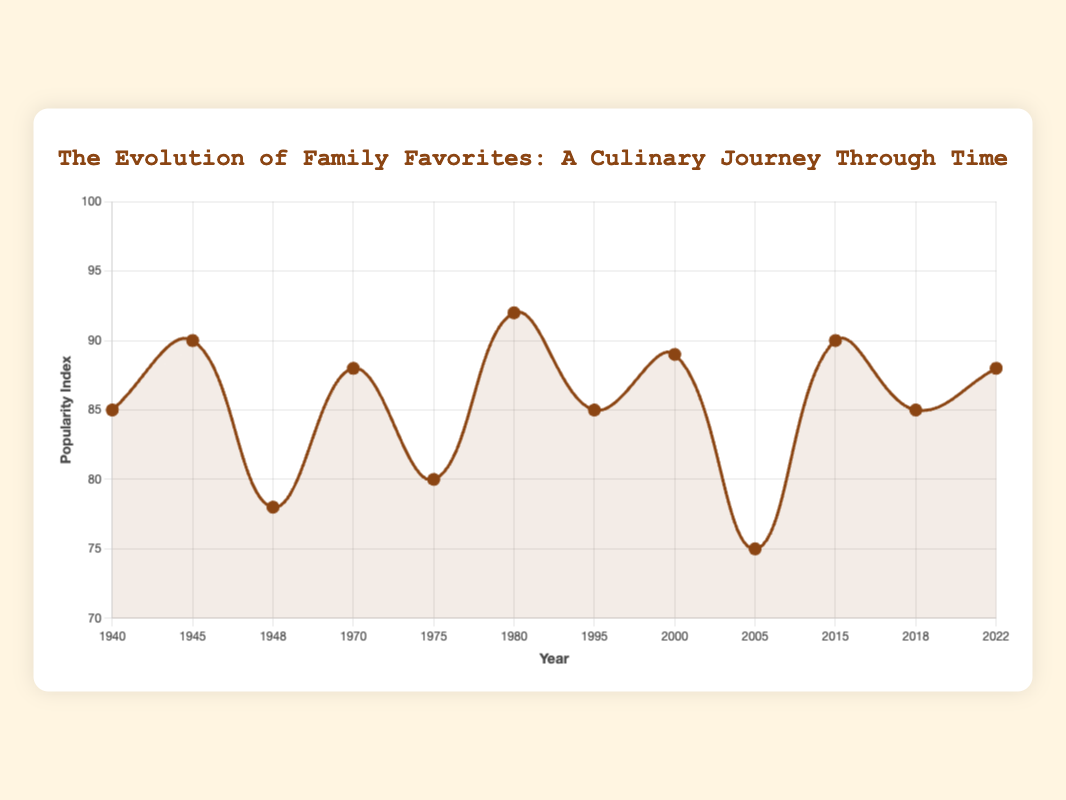What's the average popularity index for the recipes from the Great-Grandparents' generation? To find the average, sum the popularity indices of the recipes from the Great-Grandparents' generation (85 + 90 + 78 = 253) and then divide by the number of recipes (3). So, 253 / 3 ≈ 84.33
Answer: 84.33 Which generation has the highest peak in recipe popularity index, and what is this value? The peak of the popularity index can be identified as the highest point on the curve. The highest value is 92, which belongs to the Grandparents' generation (Chocolate Cake, 1980).
Answer: Grandparents, 92 How many recipes have a popularity index greater than 85? Identify the recipes with a popularity index greater than 85. They are Beef Stew (90), Spaghetti Bolognese (88), Chocolate Cake (92), Lasagna (89), Avocado Toast (90), Vegan Burgers (88). Count the recipes: 6.
Answer: 6 Visualize the data and identify the recipe with the lowest popularity index. What is it and from which year? Identify the lowest point on the curve to find the recipe with the lowest popularity index. This is the Cheeseburger with a popularity index of 75 from the year 2005.
Answer: Cheeseburger, 2005 Between which years did the popularity index show the greatest increase, and what was this increase? Look at the segments of the curve to find the steepest positive slope. From 1948 (Apple Pie, 78) to 1970 (Spaghetti Bolognese, 88), the increase is 88 - 78 = 10.
Answer: 1948 to 1970, Increase of 10 Compare the popularity indices of "Avocado Toast" and "Chocolate Cake." Which one is higher, and by how much? Avocado Toast has a popularity index of 90, while Chocolate Cake has 92. Subtract to find the difference: 92 - 90 = 2.
Answer: Chocolate Cake, 2 How does the average popularity index of the recipes from the Parents' generation compare to that of the Current generation? Calculate the average for both generations: Parents (85+89+75=249/3=83), Current (90+85+88=263/3≈87.67). Compare the averages: 87.67 - 83 = 4.67.
Answer: The Current generation is higher by 4.67 What is the median popularity index of all the recipes listed? List all popularity indices in order and find the middle value(s): (75, 78, 80, 85, 85, 88, 88, 89, 90, 90, 92). The median is the middle value 88.
Answer: 88 What recipe remained consistently popular over time across generations, and what were the popularity indices? Identify recipes with similar or equal indices over multiple generations. "Fried Chicken" has a popularity index of 80 (1975), no similar trend found, so none remain consistently popular.
Answer: None 